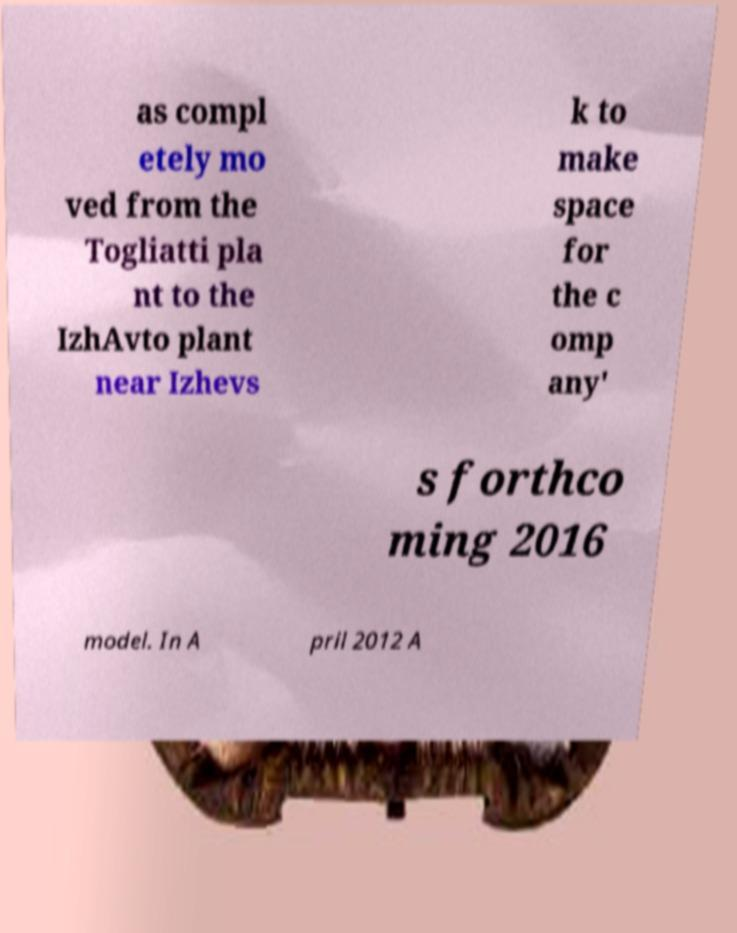Can you accurately transcribe the text from the provided image for me? as compl etely mo ved from the Togliatti pla nt to the IzhAvto plant near Izhevs k to make space for the c omp any' s forthco ming 2016 model. In A pril 2012 A 